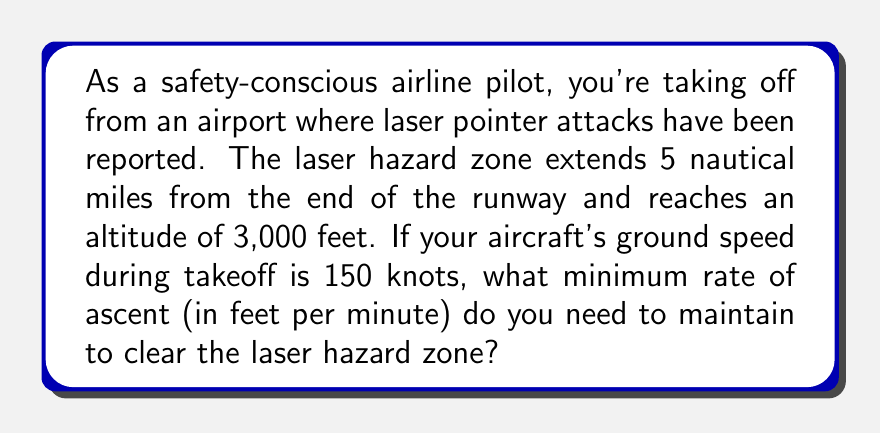What is the answer to this math problem? To solve this problem, we need to follow these steps:

1. Convert the distance to feet:
   5 nautical miles = 5 * 6,076.12 feet = 30,380.6 feet

2. Calculate the time it takes to cover this distance:
   Time = Distance / Speed
   $$ t = \frac{30,380.6 \text{ ft}}{150 \text{ knots} * 1.68781 \text{ ft/s/knot}} = 120 \text{ seconds} $$

3. Calculate the required rate of ascent:
   Rate of ascent = Altitude to reach / Time
   $$ \text{Rate of ascent} = \frac{3,000 \text{ ft}}{120 \text{ s}} * 60 \text{ s/min} = 1,500 \text{ ft/min} $$

Therefore, to clear the laser hazard zone, you need to maintain a minimum rate of ascent of 1,500 feet per minute.

[asy]
import graph;
size(200,150);

// Draw runway and hazard zone
draw((0,0)--(50,0), arrow=Arrow(TeXHead));
draw((50,0)--(200,60), dashed);
draw((50,0)--(200,0), dashed);

// Label points
label("Runway", (25,0), S);
label("5 NM", (125,0), S);
label("3,000 ft", (200,30), E);
label("Laser hazard zone", (125,30), NE);

// Draw ascent path
draw((50,0)--(200,60), arrow=Arrow(TeXHead), p=red);
label("Aircraft path", (125,30), SE, red);
[/asy]
Answer: The minimum rate of ascent needed to clear the laser hazard zone is 1,500 feet per minute. 